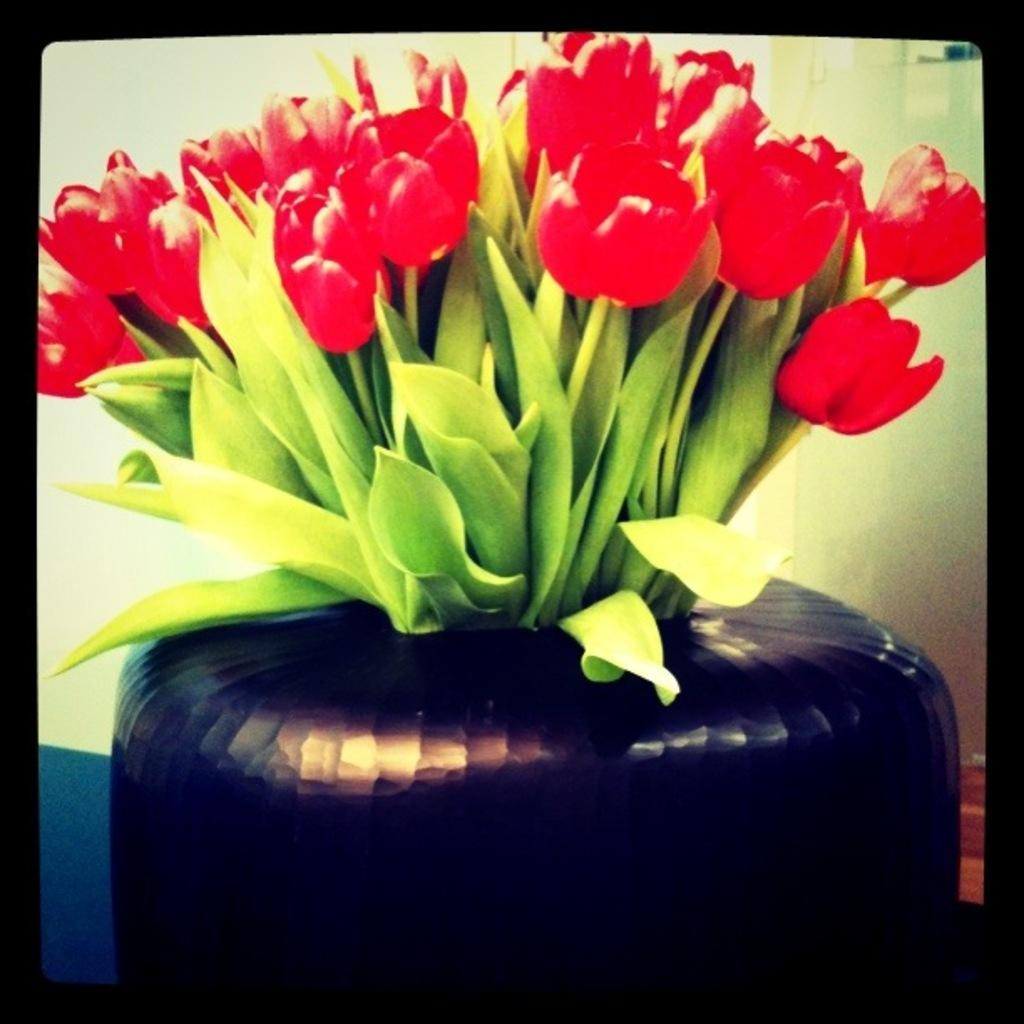What is the main object in the image? There is a flower vase in the image. What color are the flowers in the vase? The flowers in the vase are red. What is the color of the border surrounding the image? The image has a black border. What can be seen in the background of the image? There is a well in the background of the image. What type of chain is hanging from the well in the image? There is no chain hanging from the well in the image; it only shows a well in the background. How many trees are present in the plantation visible in the image? There is no plantation or trees visible in the image; it only features a well in the background. 